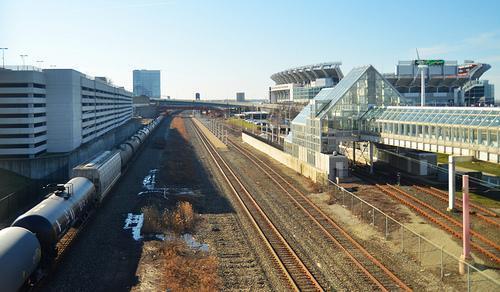How many stadiums are there?
Give a very brief answer. 1. 